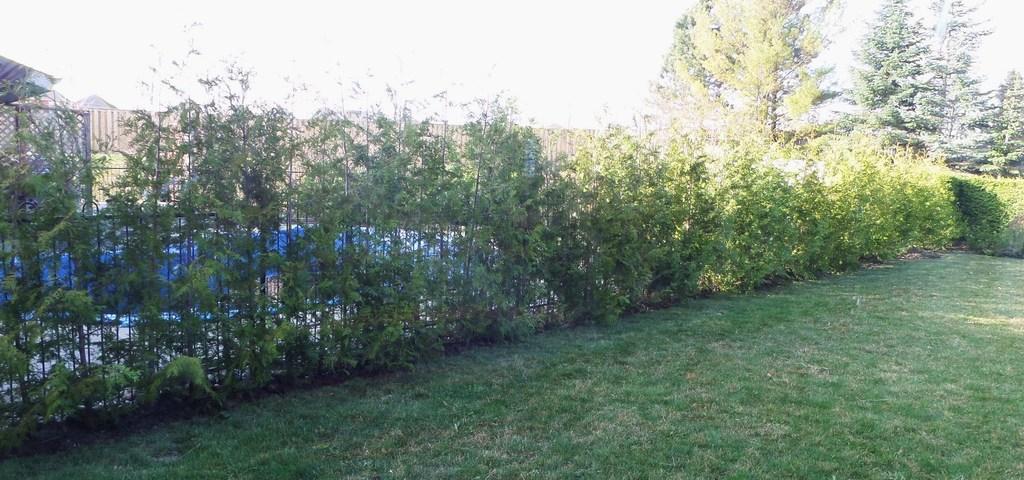Could you give a brief overview of what you see in this image? In this image we can see sky, plants, ground, trees, fence and a shed. 